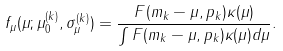Convert formula to latex. <formula><loc_0><loc_0><loc_500><loc_500>f _ { \mu } ( \mu ; \mu _ { 0 } ^ { ( k ) } , \sigma _ { \mu } ^ { ( k ) } ) = \frac { F ( m _ { k } - \mu , p _ { k } ) \kappa ( \mu ) } { \int F ( m _ { k } - \mu , p _ { k } ) \kappa ( \mu ) d \mu } .</formula> 